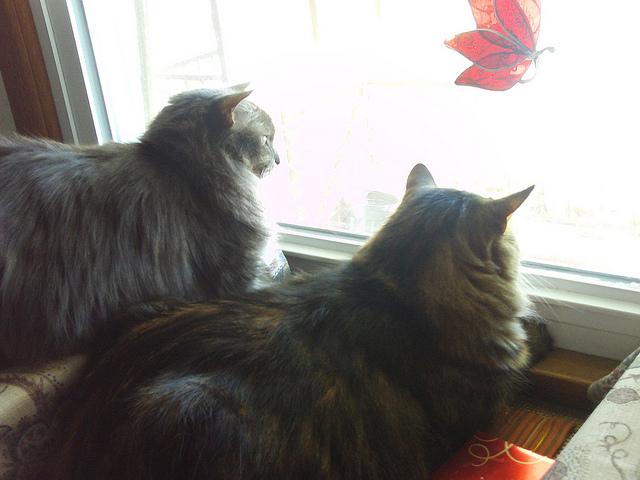What is on the window?
Keep it brief. Butterfly. What species of cats is looking outside the window?
Give a very brief answer. Main coon. What color is the flower?
Be succinct. Red. 